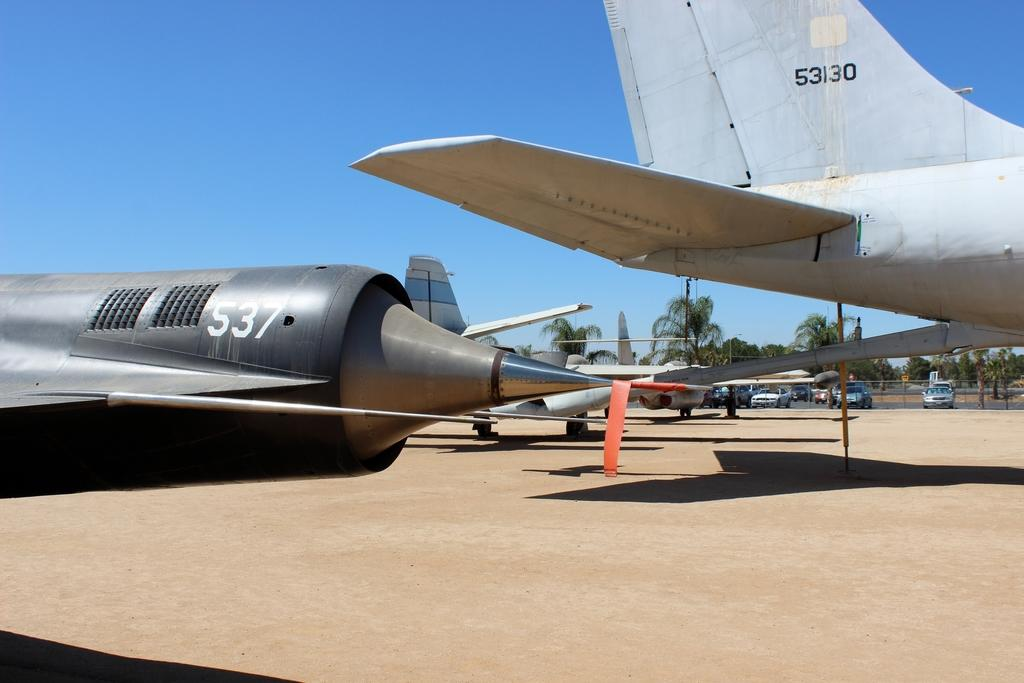<image>
Present a compact description of the photo's key features. A 537 jet plane is parked on a field with some other planes. 